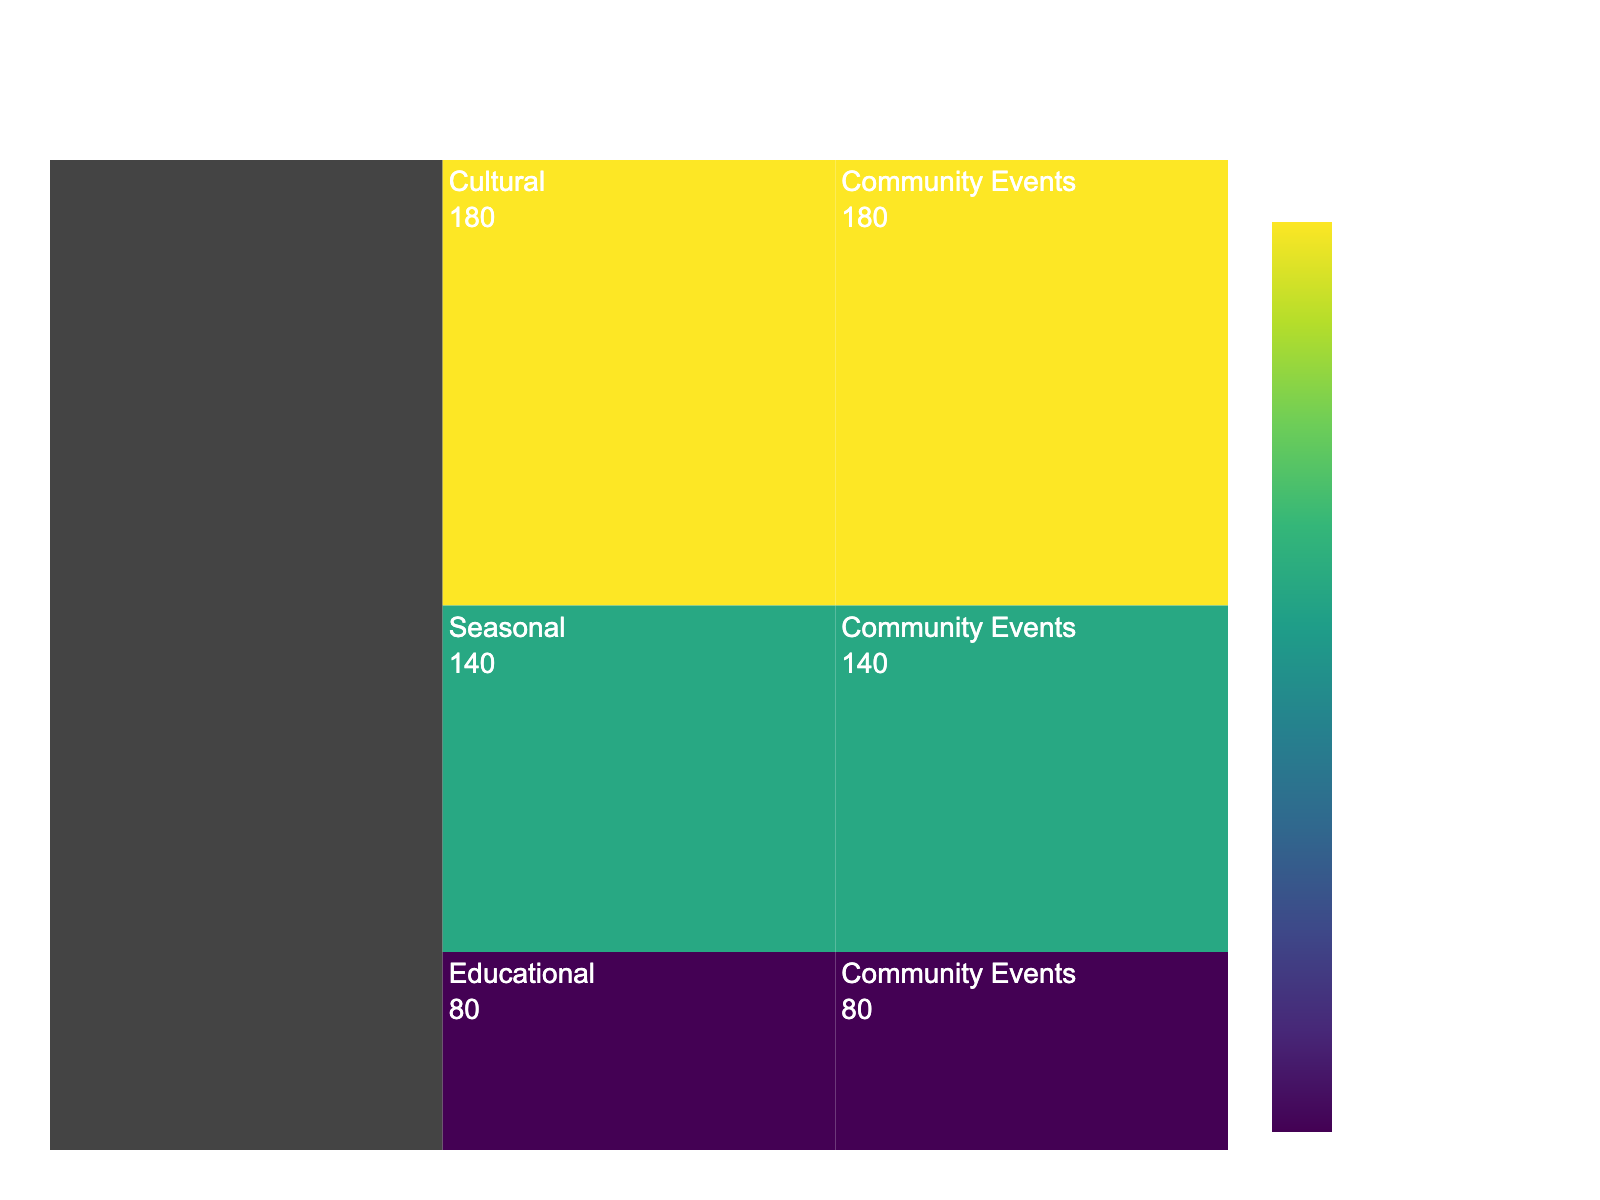What's the title of the figure? The title of the figure is written at the top, centered and large in size. It reads "Breakdown of Community Event Participation in Žaliūkės".
Answer: Breakdown of Community Event Participation in Žaliūkės How many main categories of events are there? The figure shows the main categories as the first level of the icicle chart. There are three categories displayed at this level.
Answer: 3 Which event category has the highest number of participants? By looking at the largest colored area or the highest numerical value within the icicle chart, the Cultural category has the highest number of participants.
Answer: Cultural What's the total number of participants across all community events? Summing up the participants from each category: 180 (Cultural) + 140 (Seasonal) + 80 (Educational) equals 400 participants in total.
Answer: 400 How many participants attended the Educational events? The value associated with the Educational category in the icicle chart is directly stated as 80 participants.
Answer: 80 How many more participants attended Cultural events compared to Seasonal events? The number of participants in Cultural events is 180, and in Seasonal events is 140. The difference is calculated as 180 - 140 = 40.
Answer: 40 What percentage of participants attended the Seasonal events out of the total community event participation? The number of participants in Seasonal events is 140. The total participants are 400. The percentage is (140 / 400) * 100 = 35%.
Answer: 35% Compare the ratio of participants in Educational events to those in Cultural events. The number of participants in Educational events is 80, and in Cultural events is 180. The ratio is calculated as 80 / 180, which simplifies to approximately 4:9.
Answer: 4:9 Which event category has the smallest participant count? The smallest numerical value within the categories of the icicle chart is for the Educational category, which has 80 participants.
Answer: Educational What's the average number of participants per event category? The total number of participants is 400, and there are 3 categories. The average number of participants per category is 400 / 3, which equals approximately 133.33.
Answer: 133.33 